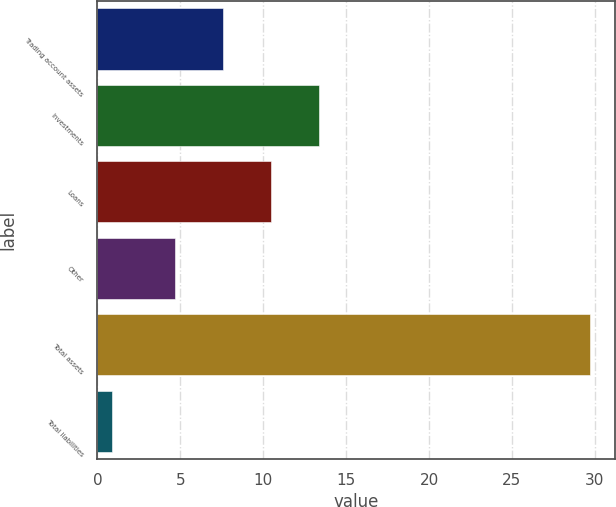Convert chart to OTSL. <chart><loc_0><loc_0><loc_500><loc_500><bar_chart><fcel>Trading account assets<fcel>Investments<fcel>Loans<fcel>Other<fcel>Total assets<fcel>Total liabilities<nl><fcel>7.58<fcel>13.34<fcel>10.46<fcel>4.7<fcel>29.7<fcel>0.9<nl></chart> 